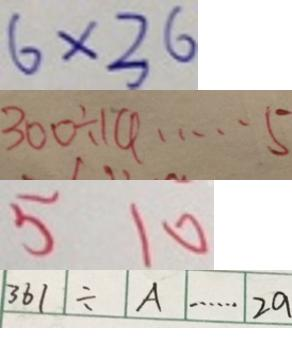<formula> <loc_0><loc_0><loc_500><loc_500>6 \times 3 6 
 3 0 0 \div 1 4 \cdots 5 
 5 1 0 
 3 6 1 \div A \cdots 2 a</formula> 